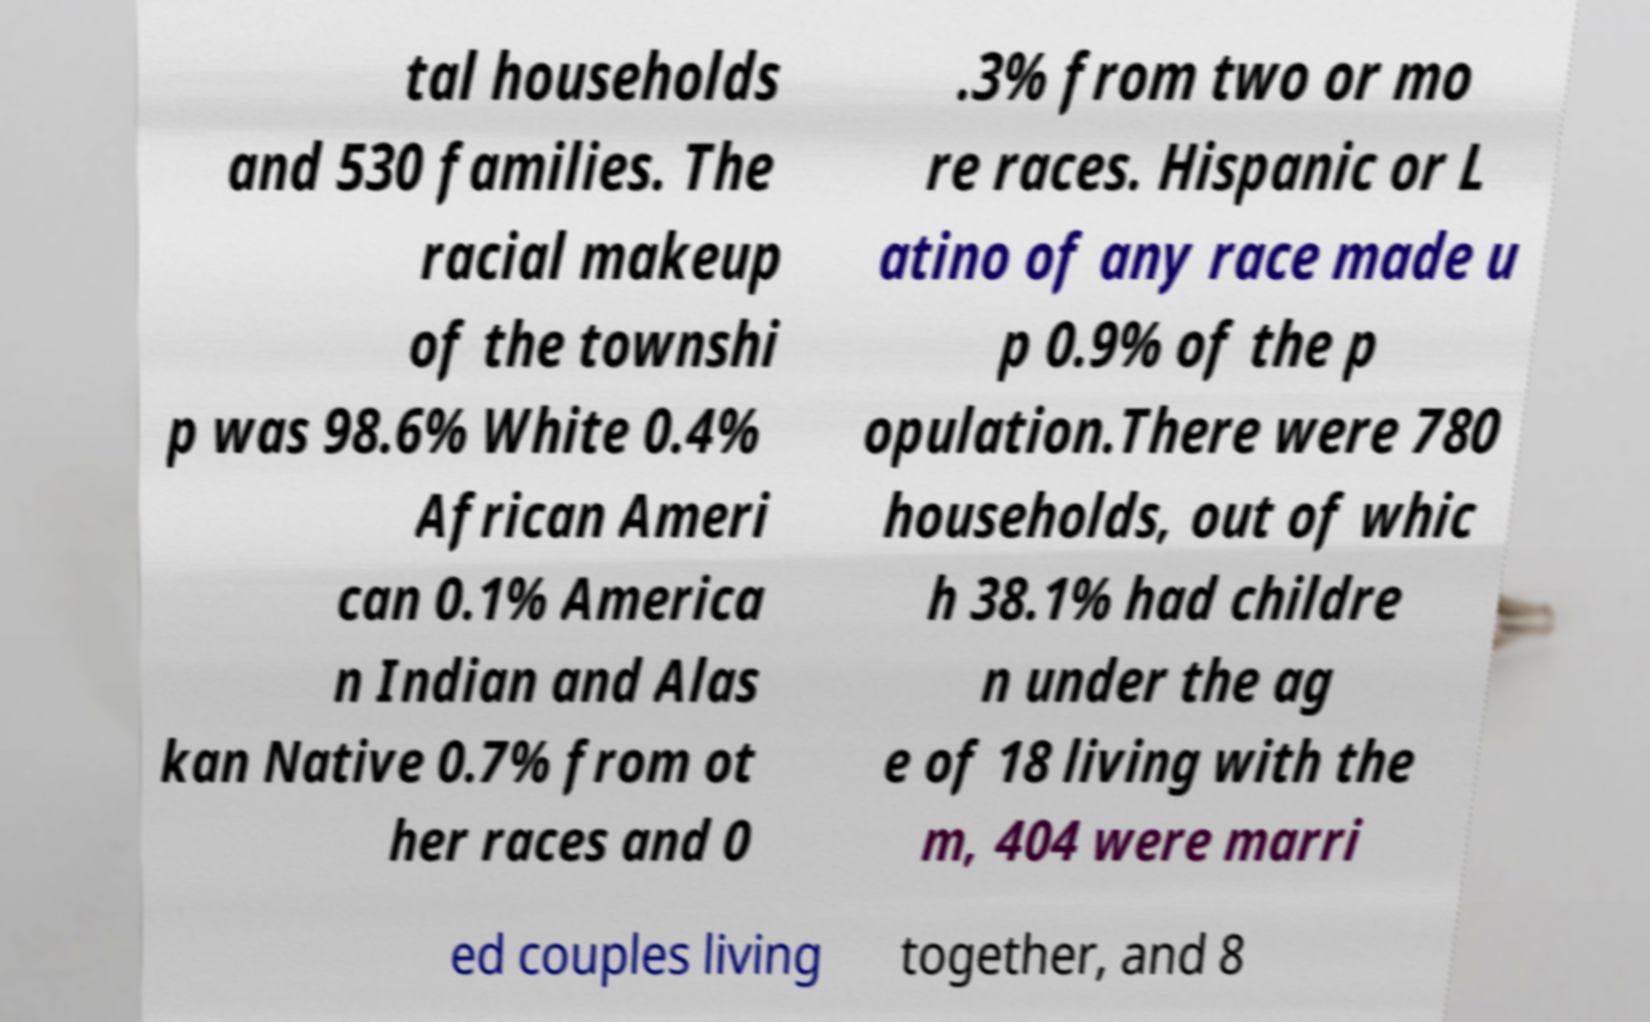Could you extract and type out the text from this image? tal households and 530 families. The racial makeup of the townshi p was 98.6% White 0.4% African Ameri can 0.1% America n Indian and Alas kan Native 0.7% from ot her races and 0 .3% from two or mo re races. Hispanic or L atino of any race made u p 0.9% of the p opulation.There were 780 households, out of whic h 38.1% had childre n under the ag e of 18 living with the m, 404 were marri ed couples living together, and 8 